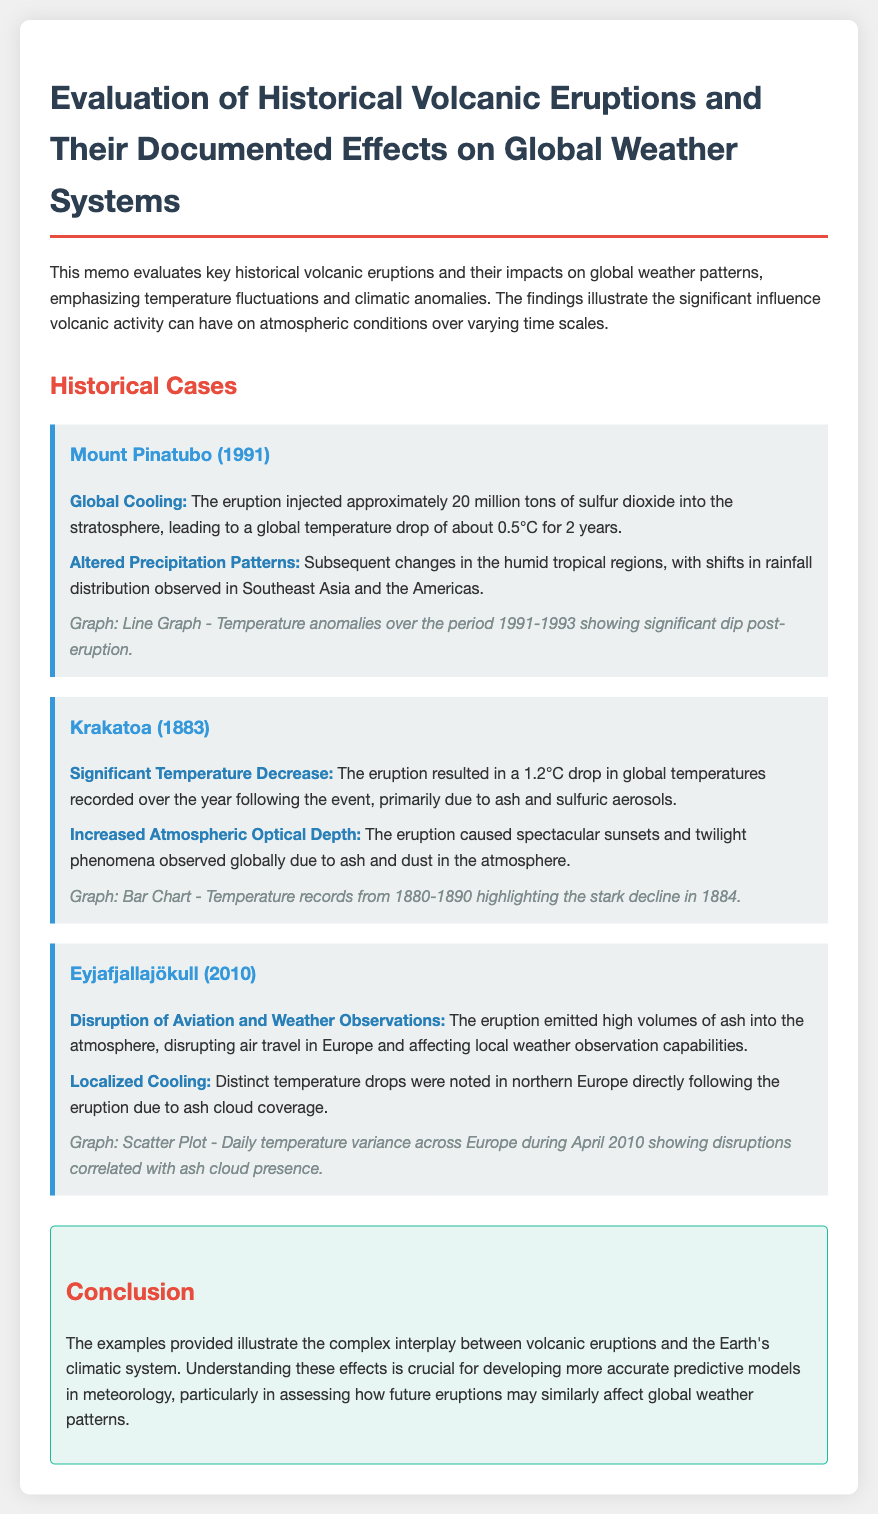What eruption happened in 1991? The document states that Mount Pinatubo erupted in 1991.
Answer: Mount Pinatubo What was the global temperature drop caused by the Krakatoa eruption? The document indicates a 1.2°C drop in global temperatures due to the Krakatoa eruption.
Answer: 1.2°C What years did the temperature anomalies occur for Mount Pinatubo? The document specifies that the temperature anomalies occurred during 1991-1993.
Answer: 1991-1993 What effect did the Eyjafjallajökull eruption have on aviation? The memo mentions that the eruption disrupted air travel in Europe.
Answer: Disrupted air travel What is the primary cause of global cooling after volcanic eruptions? The document suggests that sulfur dioxide and aerosols injected into the atmosphere are responsible for cooling.
Answer: Sulfur dioxide How many tons of sulfur dioxide were injected by Mount Pinatubo? The memo states that approximately 20 million tons of sulfur dioxide were injected into the stratosphere.
Answer: 20 million tons What type of graph represents the temperature anomalies for Mount Pinatubo? The document specifies a line graph was used to depict temperature anomalies for Mount Pinatubo.
Answer: Line Graph What atmospheric phenomenon was observed due to the Krakatoa eruption? The document discusses spectacular sunsets and twilight phenomena observed globally.
Answer: Spectacular sunsets What impact did the 2010 eruption have on local weather observation? The memo notes that the eruption affected local weather observation capabilities.
Answer: Affected capabilities 